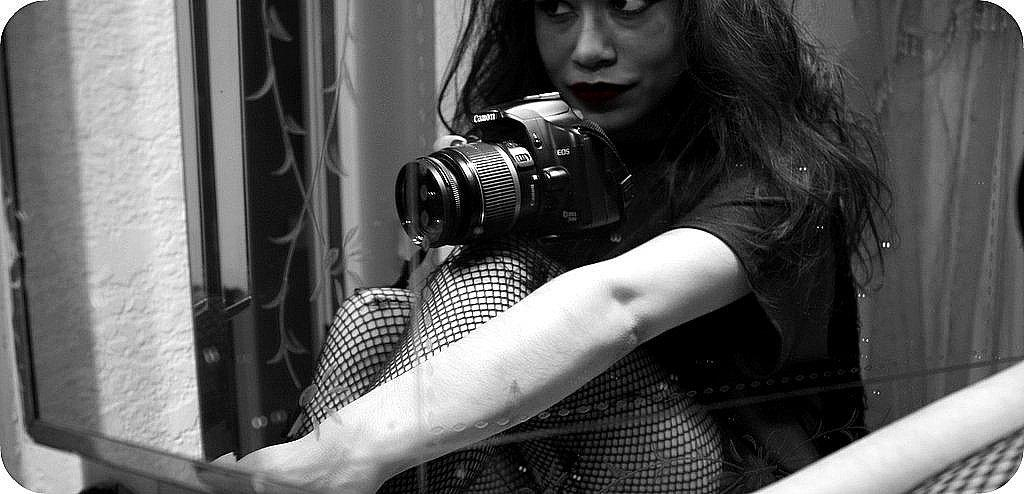Who is the main subject in the image? There is a woman in the image. What is the woman doing in the image? The woman is sitting in the image. What is the woman holding in the image? The woman is holding a camera in the image. What can be seen on the left side of the image? There is a wall on the left side of the image. What type of humor can be seen in the image? There is no humor present in the image; it is a woman sitting and holding a camera. How many minutes are depicted in the image? The concept of time in minutes is not applicable to the image, as it is a still photograph. 